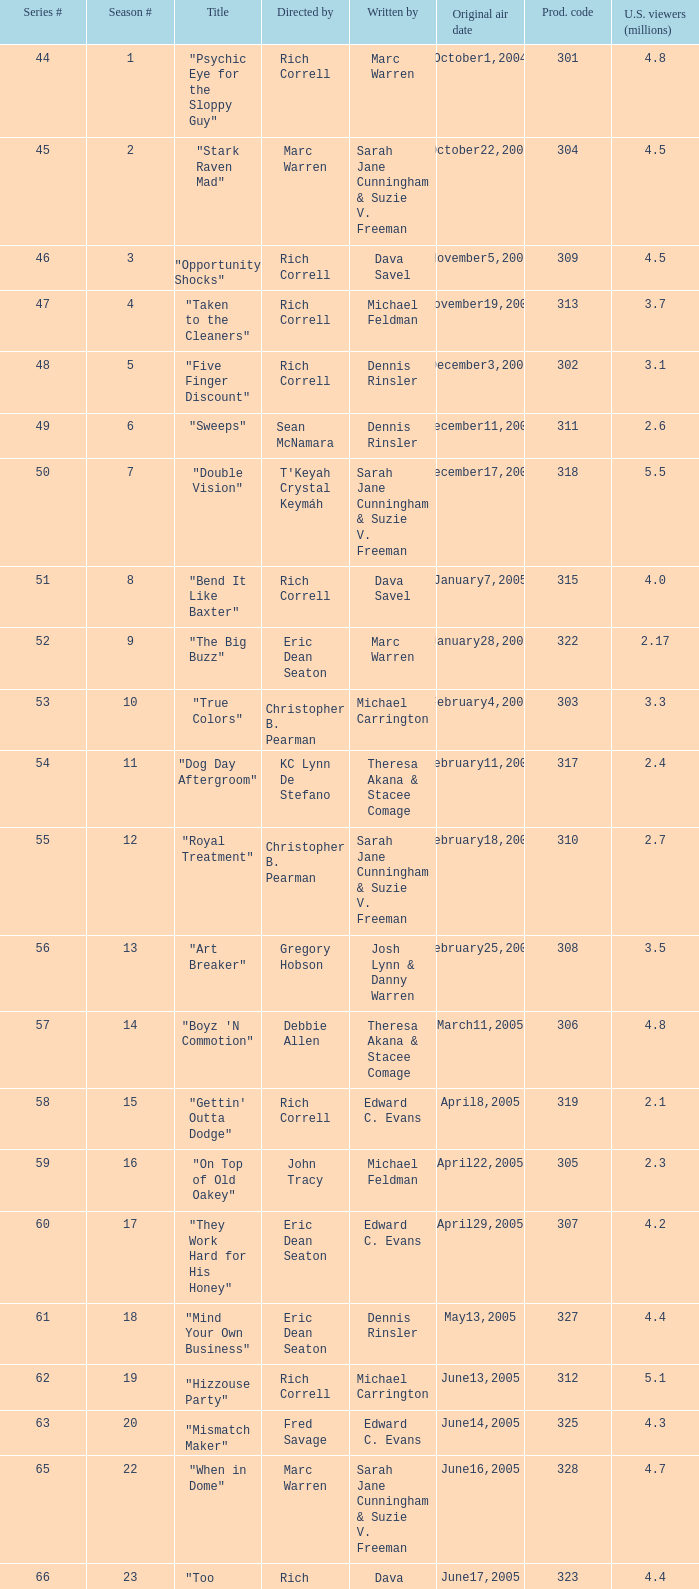For which episode in the season was the title "vision impossible" used? 34.0. 